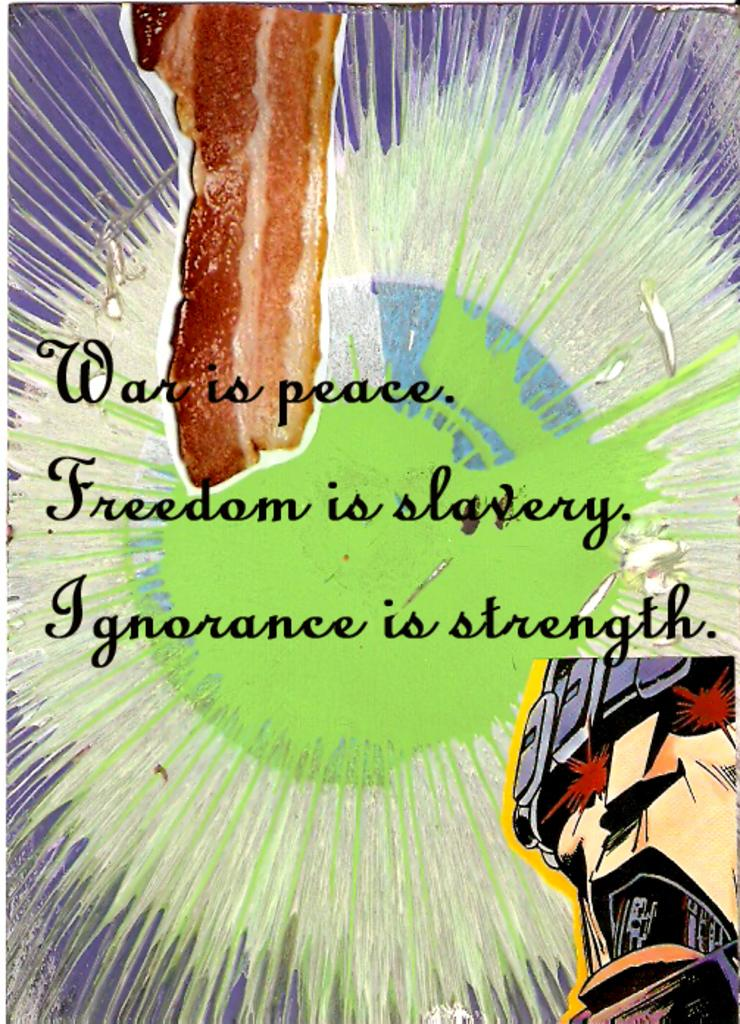<image>
Give a short and clear explanation of the subsequent image. Colorful background featuring a host of edgy quotes such as "War is peace". 